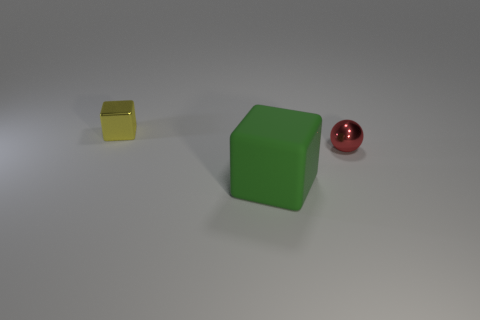Subtract 1 red spheres. How many objects are left? 2 Subtract all cubes. How many objects are left? 1 Subtract 2 blocks. How many blocks are left? 0 Subtract all green balls. Subtract all green cubes. How many balls are left? 1 Subtract all red spheres. How many green cubes are left? 1 Subtract all green metallic balls. Subtract all metallic balls. How many objects are left? 2 Add 2 tiny metallic balls. How many tiny metallic balls are left? 3 Add 2 large green blocks. How many large green blocks exist? 3 Add 3 tiny balls. How many objects exist? 6 Subtract all yellow blocks. How many blocks are left? 1 